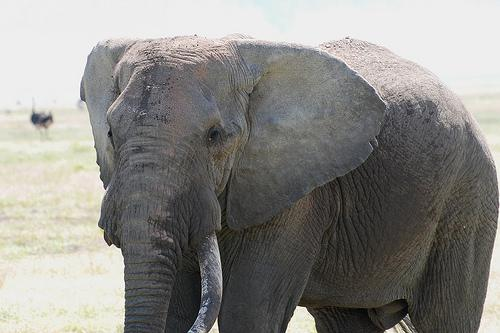What type of habitat is the main subject in and what other creatures can be seen in the background? The elephant is in a grassy field, possibly a forest, and there are two ostriches or emus standing in the background. Identify the primary animal in the image and give a few details about it. The primary animal in the image is a big, grey, wrinkled elephant with large ears, a large tusk, and small eyes compared to its size. Describe the main subject's physical appearance focusing on color and texture. The main subject, the elephant, has grey, wrinkled skin with noticeable folds and a large, aged appearance. How many birds are there in the image and what are their distinguishing attributes? There are two tall birds in the image, possibly ostriches or emus, with long necks and black and brown bodies. What are some unique or interesting aspects of the elephant's appearance that make it stand out in the image? The unique aspects of the elephant's appearance include its large tusk, small eyes, big ears, and its wrinkled, grey skin. Describe the interaction between the primary animal and the background elements. The elephant is standing in the forefront with the two tall birds, either ostriches or emus, visible in the background amidst a grassy field. Mention the elephant's legs and how they look in the image. The legs of the elephant are grey, wrinkled, and appear to be sturdy, with front and hind legs visible in the image. Provide a brief description of the elephant's ears and eyes. The elephant's ears are very large, grey, and wrinkled, while its eyes are small compared to the rest of its size. Provide a brief description of the elephant's facial features. The elephant has small eyes, a long trunk, large tusk, and big ears which are all grey and wrinkled. What are some notable aspects of the grass in the image, such as its color and location? The grass in the image is green in color and can be found in patches, with the main subject standing in a grassy field. 